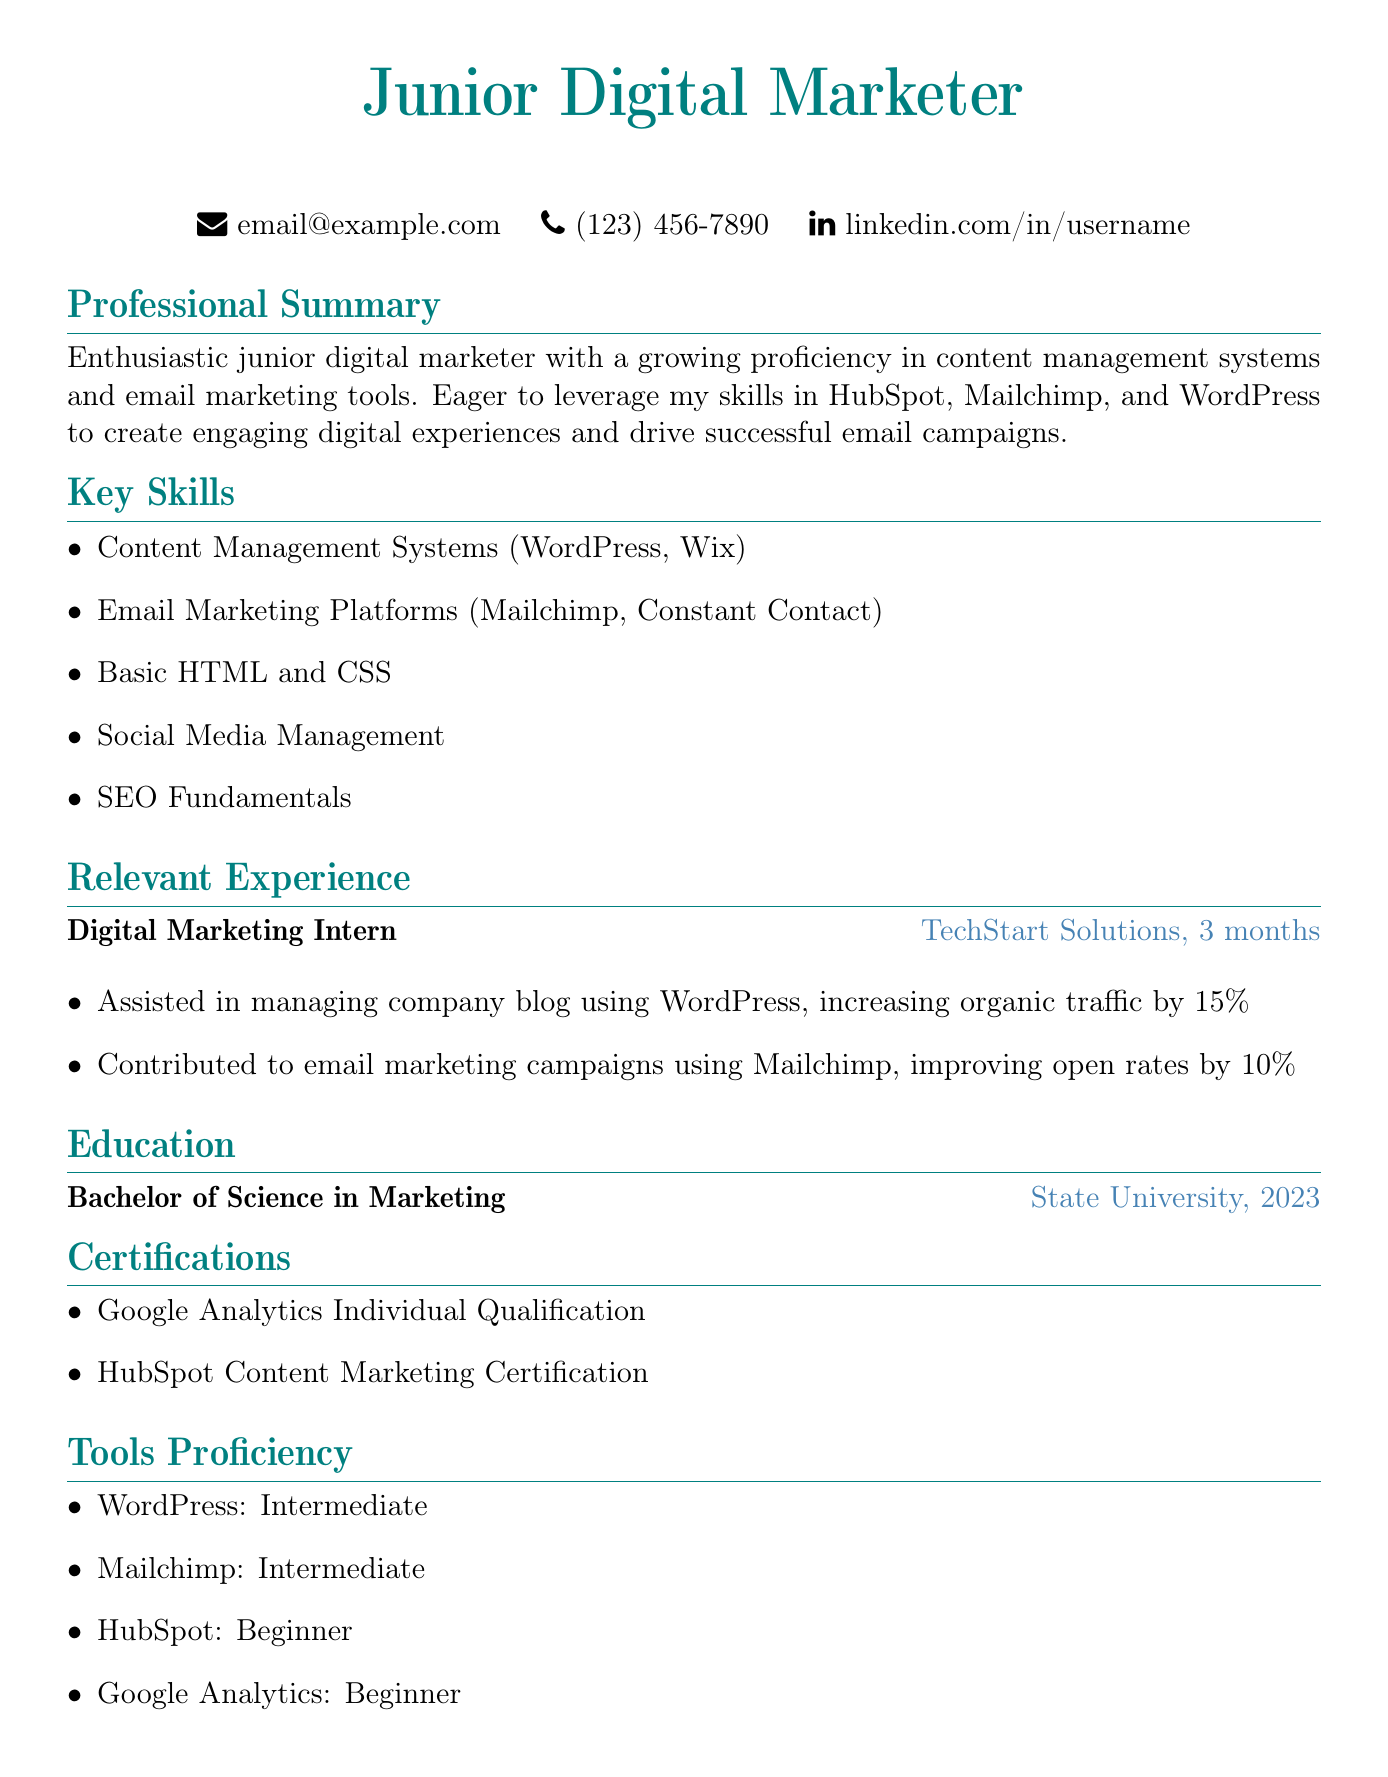What is the position held during the internship? The position mentioned in the document under relevant experience is related to the internship at TechStart Solutions.
Answer: Digital Marketing Intern What tools has the applicant listed as having intermediate proficiency? The tools proficiency section includes WordPress and Mailchimp as intermediate skills.
Answer: WordPress, Mailchimp What degree has the applicant obtained? The education section clearly states the degree received by the applicant from State University.
Answer: Bachelor of Science in Marketing How long did the internship last? The relevant experience section specifies the duration of the internship at TechStart Solutions.
Answer: 3 months What was the percentage increase in organic traffic due to blog management? The achievements under relevant experience indicate a specific percentage increase attributed to blog management using WordPress.
Answer: 15% Which email marketing platform is mentioned as a tool used? The professional summary and relevant experience sections both indicated usage of this platform in digital marketing efforts.
Answer: Mailchimp What certification does the applicant have related to content marketing? The certifications section reveals a specific course completed by the applicant that relates to content marketing skills.
Answer: HubSpot Content Marketing Certification What institution did the applicant graduate from? The education section explicitly names the university from which the applicant graduated.
Answer: State University Which fundamental area of digital marketing is mentioned in the key skills? The key skills section includes a specific digital marketing area that is crucial for search engines.
Answer: SEO Fundamentals 